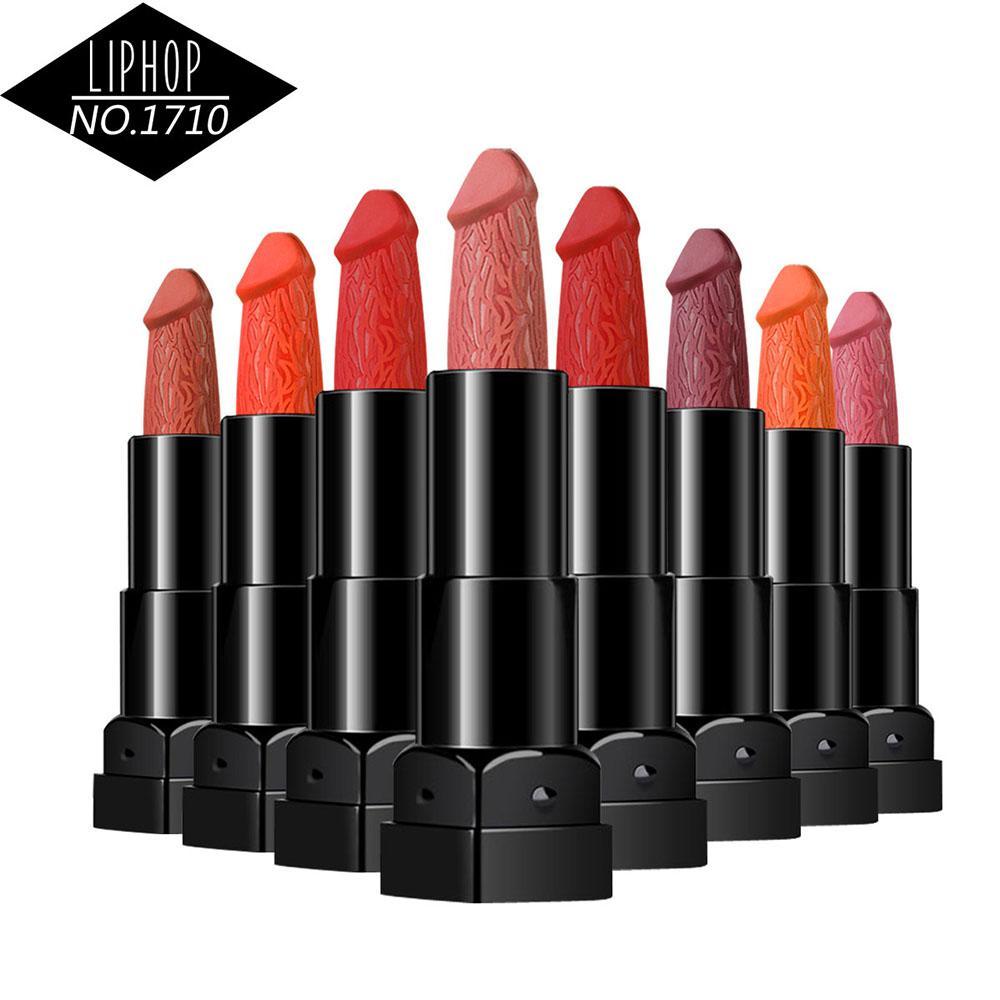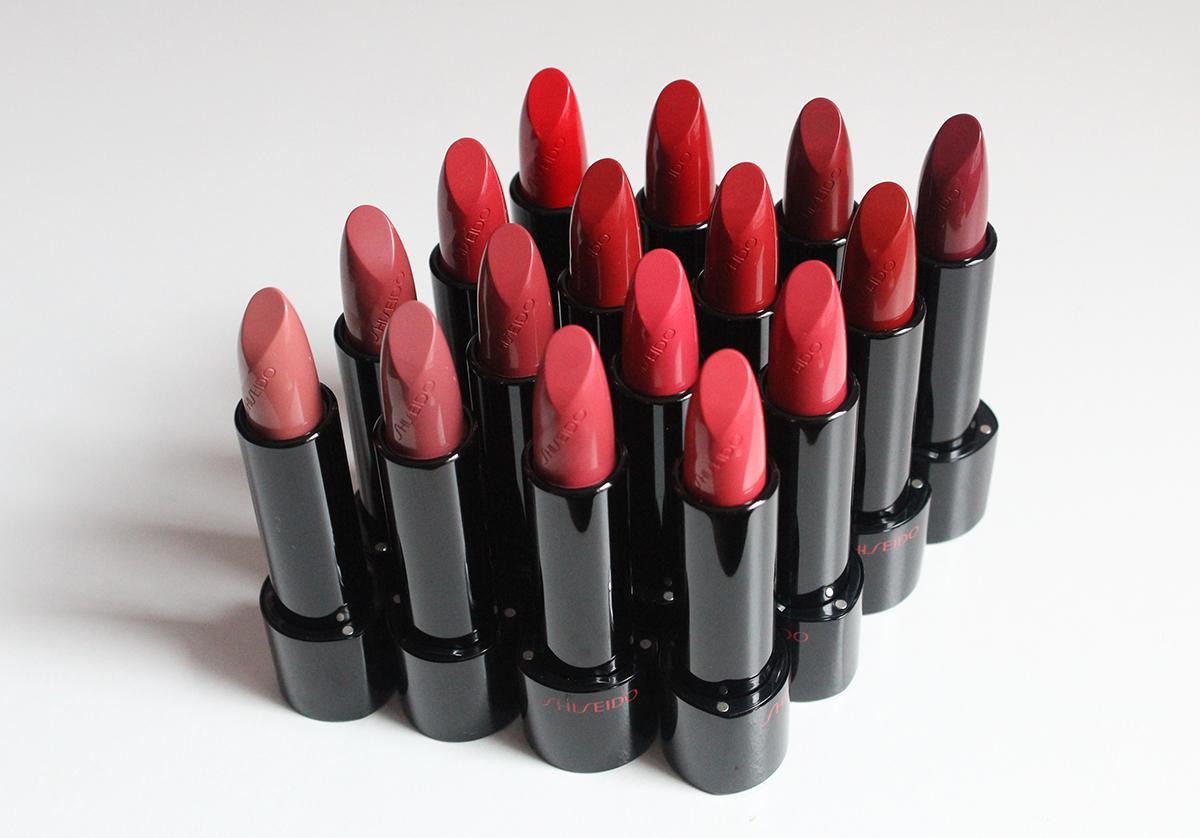The first image is the image on the left, the second image is the image on the right. Considering the images on both sides, is "There are sixteen lipsticks in the right image." valid? Answer yes or no. Yes. The first image is the image on the left, the second image is the image on the right. Assess this claim about the two images: "The lipsticks are arranged in the shape of a diamond.". Correct or not? Answer yes or no. Yes. 